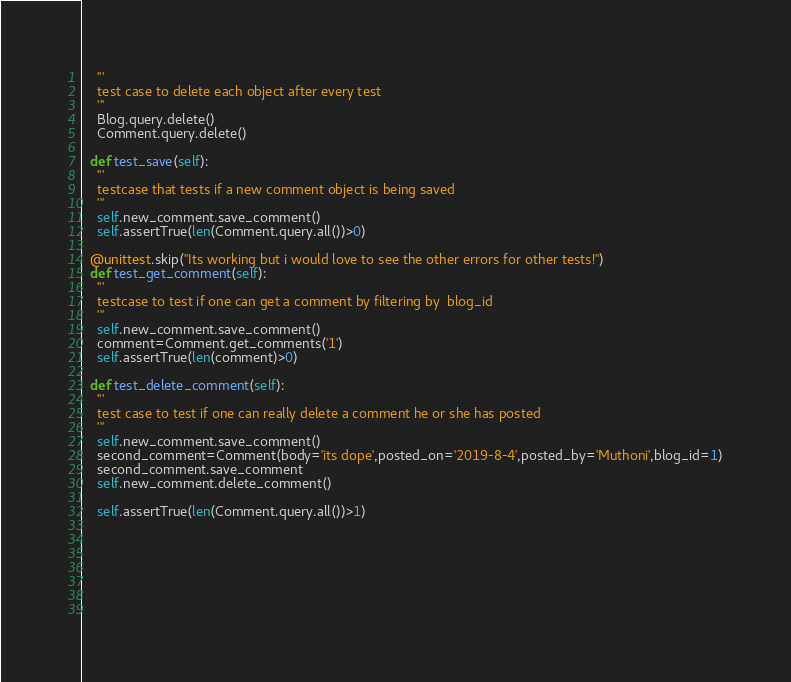<code> <loc_0><loc_0><loc_500><loc_500><_Python_>    '''
    test case to delete each object after every test
    '''
    Blog.query.delete()
    Comment.query.delete()

  def test_save(self):
    '''
    testcase that tests if a new comment object is being saved
    '''
    self.new_comment.save_comment()
    self.assertTrue(len(Comment.query.all())>0)

  @unittest.skip("Its working but i would love to see the other errors for other tests!")
  def test_get_comment(self):
    '''
    testcase to test if one can get a comment by filtering by  blog_id
    '''
    self.new_comment.save_comment()
    comment=Comment.get_comments('1')
    self.assertTrue(len(comment)>0)
  
  def test_delete_comment(self):
    '''
    test case to test if one can really delete a comment he or she has posted
    '''
    self.new_comment.save_comment()
    second_comment=Comment(body='its dope',posted_on='2019-8-4',posted_by='Muthoni',blog_id=1)
    second_comment.save_comment
    self.new_comment.delete_comment()

    self.assertTrue(len(Comment.query.all())>1)


      
    


    

</code> 